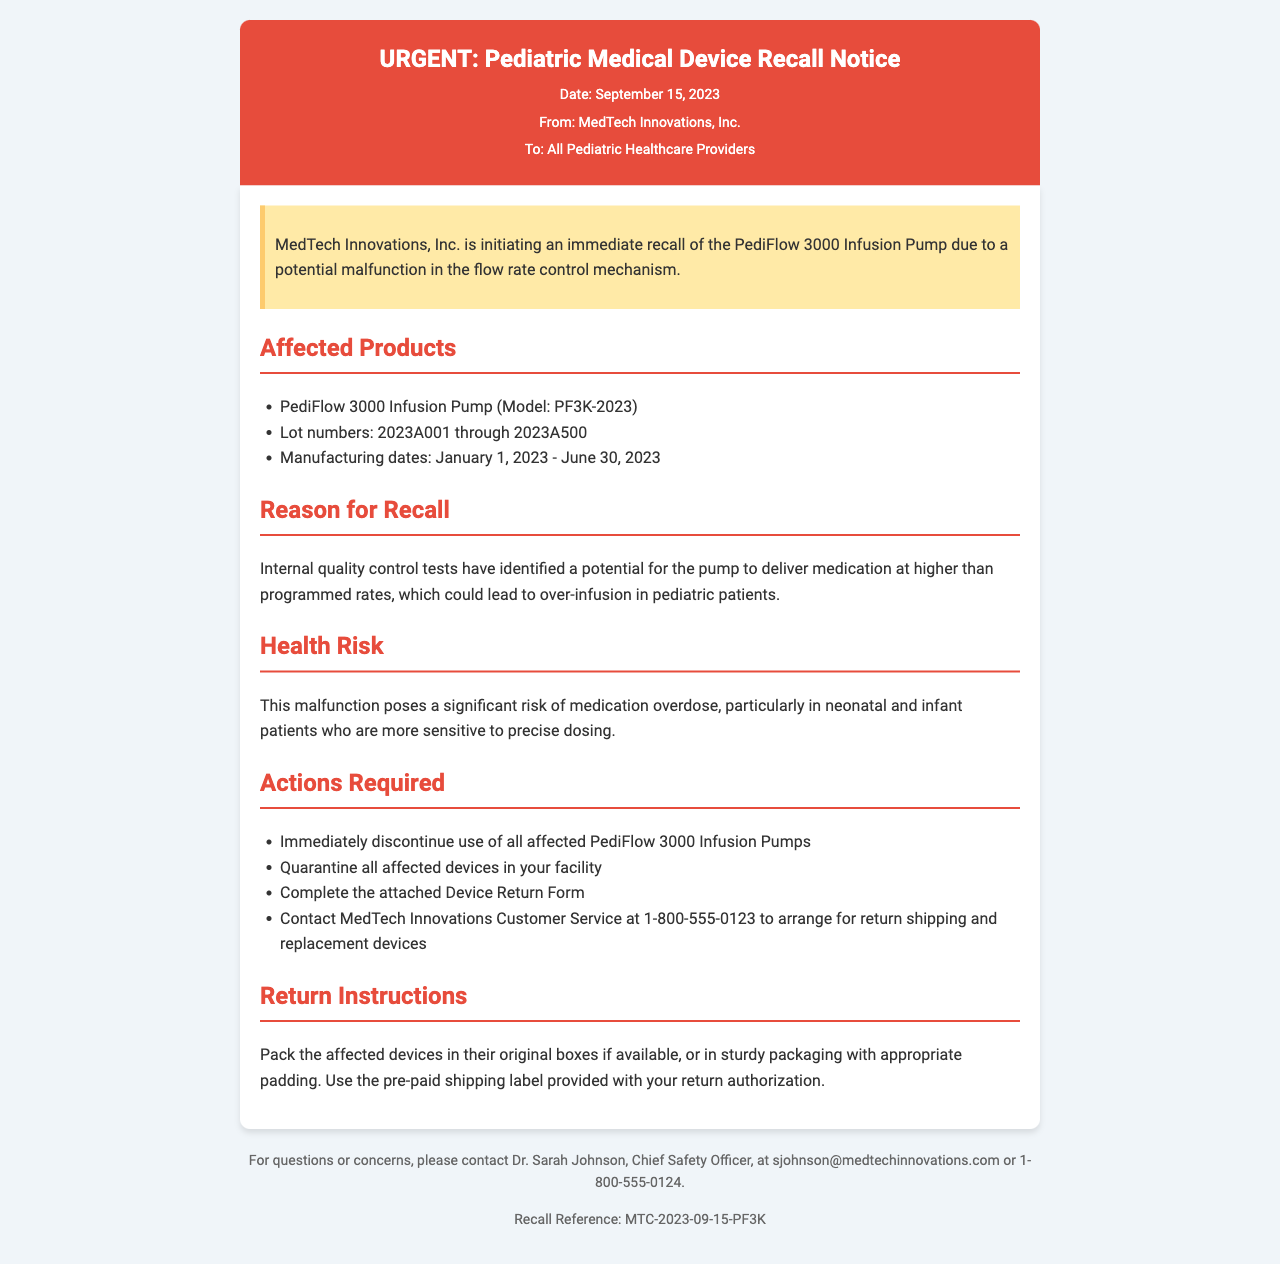what is the model of the affected device? The document specifies the model of the affected device as PediFlow 3000 Infusion Pump (Model: PF3K-2023).
Answer: PediFlow 3000 Infusion Pump (Model: PF3K-2023) what is the lot number range for the recall? The document lists the lot numbers for the recalled devices as ranging from 2023A001 through 2023A500.
Answer: 2023A001 through 2023A500 what is the manufacturing date range for affected products? The document states that the manufacturing dates for affected products are from January 1, 2023 to June 30, 2023.
Answer: January 1, 2023 - June 30, 2023 who should be contacted for device return arrangements? The document instructs to contact MedTech Innovations Customer Service for return shipping and replacement devices.
Answer: MedTech Innovations Customer Service what potential health risk is mentioned? The document highlights the risk of medication overdose as a significant health risk.
Answer: Medication overdose what action must be taken regarding the affected devices? The document requires that all affected PediFlow 3000 Infusion Pumps be immediately discontinued from use.
Answer: Immediately discontinue use what is the reference number for this recall? The document provides a recall reference number that is MTC-2023-09-15-PF3K.
Answer: MTC-2023-09-15-PF3K what is the date of this recall notification? The document states that the date of the recall notification is September 15, 2023.
Answer: September 15, 2023 where should affected devices be packed for return? The document suggests packing affected devices in their original boxes or sturdy packaging with padding for return shipping.
Answer: Original boxes or sturdy packaging with padding 